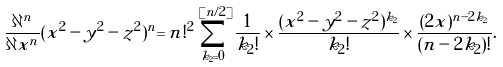<formula> <loc_0><loc_0><loc_500><loc_500>\frac { \partial ^ { n } } { \partial x ^ { n } } ( x ^ { 2 } - y ^ { 2 } - z ^ { 2 } ) ^ { n } = n ! ^ { 2 } \sum _ { k _ { 2 } = 0 } ^ { [ n / 2 ] } \frac { 1 } { k _ { 2 } ! } \times \frac { ( x ^ { 2 } - y ^ { 2 } - z ^ { 2 } ) ^ { k _ { 2 } } } { k _ { 2 } ! } \times \frac { ( 2 x ) ^ { n - 2 k _ { 2 } } } { ( n - 2 k _ { 2 } ) ! } .</formula> 